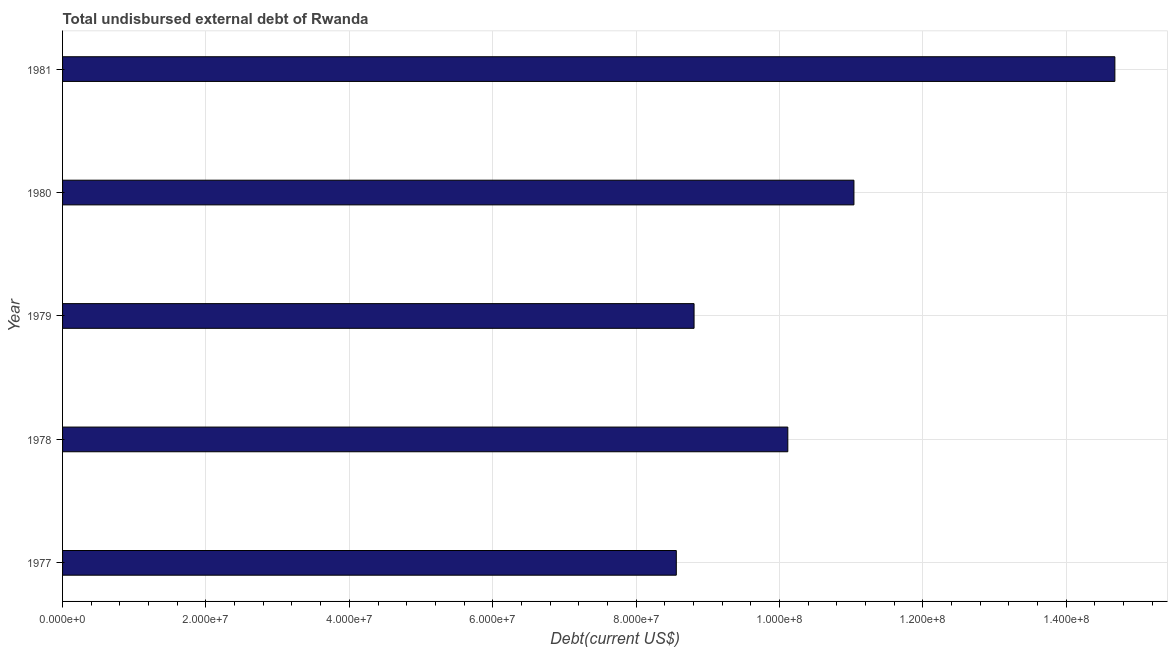What is the title of the graph?
Give a very brief answer. Total undisbursed external debt of Rwanda. What is the label or title of the X-axis?
Your response must be concise. Debt(current US$). What is the label or title of the Y-axis?
Provide a short and direct response. Year. What is the total debt in 1981?
Keep it short and to the point. 1.47e+08. Across all years, what is the maximum total debt?
Make the answer very short. 1.47e+08. Across all years, what is the minimum total debt?
Keep it short and to the point. 8.56e+07. In which year was the total debt maximum?
Make the answer very short. 1981. What is the sum of the total debt?
Offer a very short reply. 5.32e+08. What is the difference between the total debt in 1979 and 1981?
Provide a short and direct response. -5.87e+07. What is the average total debt per year?
Provide a succinct answer. 1.06e+08. What is the median total debt?
Give a very brief answer. 1.01e+08. Do a majority of the years between 1977 and 1981 (inclusive) have total debt greater than 60000000 US$?
Ensure brevity in your answer.  Yes. What is the ratio of the total debt in 1980 to that in 1981?
Your response must be concise. 0.75. Is the total debt in 1977 less than that in 1980?
Offer a terse response. Yes. Is the difference between the total debt in 1978 and 1980 greater than the difference between any two years?
Offer a very short reply. No. What is the difference between the highest and the second highest total debt?
Offer a very short reply. 3.64e+07. Is the sum of the total debt in 1977 and 1981 greater than the maximum total debt across all years?
Give a very brief answer. Yes. What is the difference between the highest and the lowest total debt?
Ensure brevity in your answer.  6.12e+07. In how many years, is the total debt greater than the average total debt taken over all years?
Your answer should be compact. 2. How many bars are there?
Provide a succinct answer. 5. Are all the bars in the graph horizontal?
Give a very brief answer. Yes. How many years are there in the graph?
Ensure brevity in your answer.  5. What is the Debt(current US$) in 1977?
Your answer should be very brief. 8.56e+07. What is the Debt(current US$) of 1978?
Your answer should be compact. 1.01e+08. What is the Debt(current US$) of 1979?
Your answer should be very brief. 8.81e+07. What is the Debt(current US$) in 1980?
Your answer should be very brief. 1.10e+08. What is the Debt(current US$) in 1981?
Offer a very short reply. 1.47e+08. What is the difference between the Debt(current US$) in 1977 and 1978?
Keep it short and to the point. -1.56e+07. What is the difference between the Debt(current US$) in 1977 and 1979?
Offer a very short reply. -2.48e+06. What is the difference between the Debt(current US$) in 1977 and 1980?
Ensure brevity in your answer.  -2.48e+07. What is the difference between the Debt(current US$) in 1977 and 1981?
Give a very brief answer. -6.12e+07. What is the difference between the Debt(current US$) in 1978 and 1979?
Make the answer very short. 1.31e+07. What is the difference between the Debt(current US$) in 1978 and 1980?
Give a very brief answer. -9.22e+06. What is the difference between the Debt(current US$) in 1978 and 1981?
Your response must be concise. -4.56e+07. What is the difference between the Debt(current US$) in 1979 and 1980?
Give a very brief answer. -2.23e+07. What is the difference between the Debt(current US$) in 1979 and 1981?
Offer a very short reply. -5.87e+07. What is the difference between the Debt(current US$) in 1980 and 1981?
Offer a terse response. -3.64e+07. What is the ratio of the Debt(current US$) in 1977 to that in 1978?
Make the answer very short. 0.85. What is the ratio of the Debt(current US$) in 1977 to that in 1980?
Ensure brevity in your answer.  0.78. What is the ratio of the Debt(current US$) in 1977 to that in 1981?
Your response must be concise. 0.58. What is the ratio of the Debt(current US$) in 1978 to that in 1979?
Your response must be concise. 1.15. What is the ratio of the Debt(current US$) in 1978 to that in 1980?
Keep it short and to the point. 0.92. What is the ratio of the Debt(current US$) in 1978 to that in 1981?
Make the answer very short. 0.69. What is the ratio of the Debt(current US$) in 1979 to that in 1980?
Provide a short and direct response. 0.8. What is the ratio of the Debt(current US$) in 1979 to that in 1981?
Keep it short and to the point. 0.6. What is the ratio of the Debt(current US$) in 1980 to that in 1981?
Give a very brief answer. 0.75. 